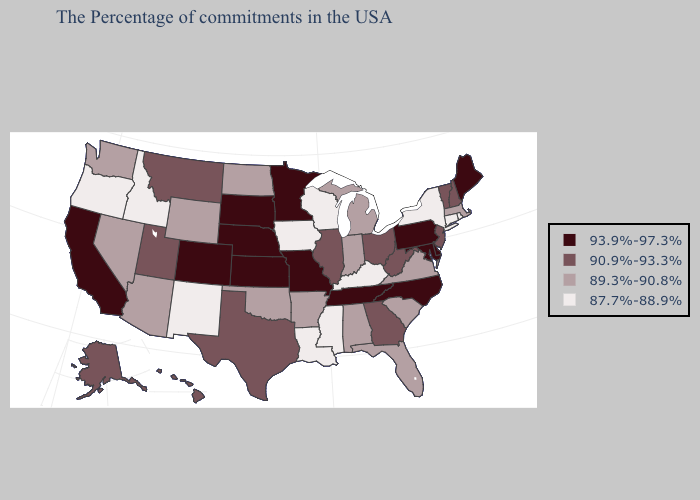What is the value of Rhode Island?
Concise answer only. 87.7%-88.9%. Does Pennsylvania have the highest value in the Northeast?
Short answer required. Yes. Does Oregon have the lowest value in the West?
Write a very short answer. Yes. Name the states that have a value in the range 90.9%-93.3%?
Write a very short answer. New Hampshire, Vermont, New Jersey, West Virginia, Ohio, Georgia, Illinois, Texas, Utah, Montana, Alaska, Hawaii. What is the lowest value in the South?
Be succinct. 87.7%-88.9%. Does Arizona have the lowest value in the USA?
Answer briefly. No. Name the states that have a value in the range 87.7%-88.9%?
Keep it brief. Rhode Island, Connecticut, New York, Kentucky, Wisconsin, Mississippi, Louisiana, Iowa, New Mexico, Idaho, Oregon. How many symbols are there in the legend?
Be succinct. 4. What is the value of South Dakota?
Keep it brief. 93.9%-97.3%. What is the value of Colorado?
Be succinct. 93.9%-97.3%. Among the states that border Wisconsin , which have the lowest value?
Concise answer only. Iowa. Name the states that have a value in the range 93.9%-97.3%?
Short answer required. Maine, Delaware, Maryland, Pennsylvania, North Carolina, Tennessee, Missouri, Minnesota, Kansas, Nebraska, South Dakota, Colorado, California. Which states hav the highest value in the Northeast?
Answer briefly. Maine, Pennsylvania. Among the states that border Indiana , does Illinois have the lowest value?
Write a very short answer. No. Name the states that have a value in the range 87.7%-88.9%?
Quick response, please. Rhode Island, Connecticut, New York, Kentucky, Wisconsin, Mississippi, Louisiana, Iowa, New Mexico, Idaho, Oregon. 